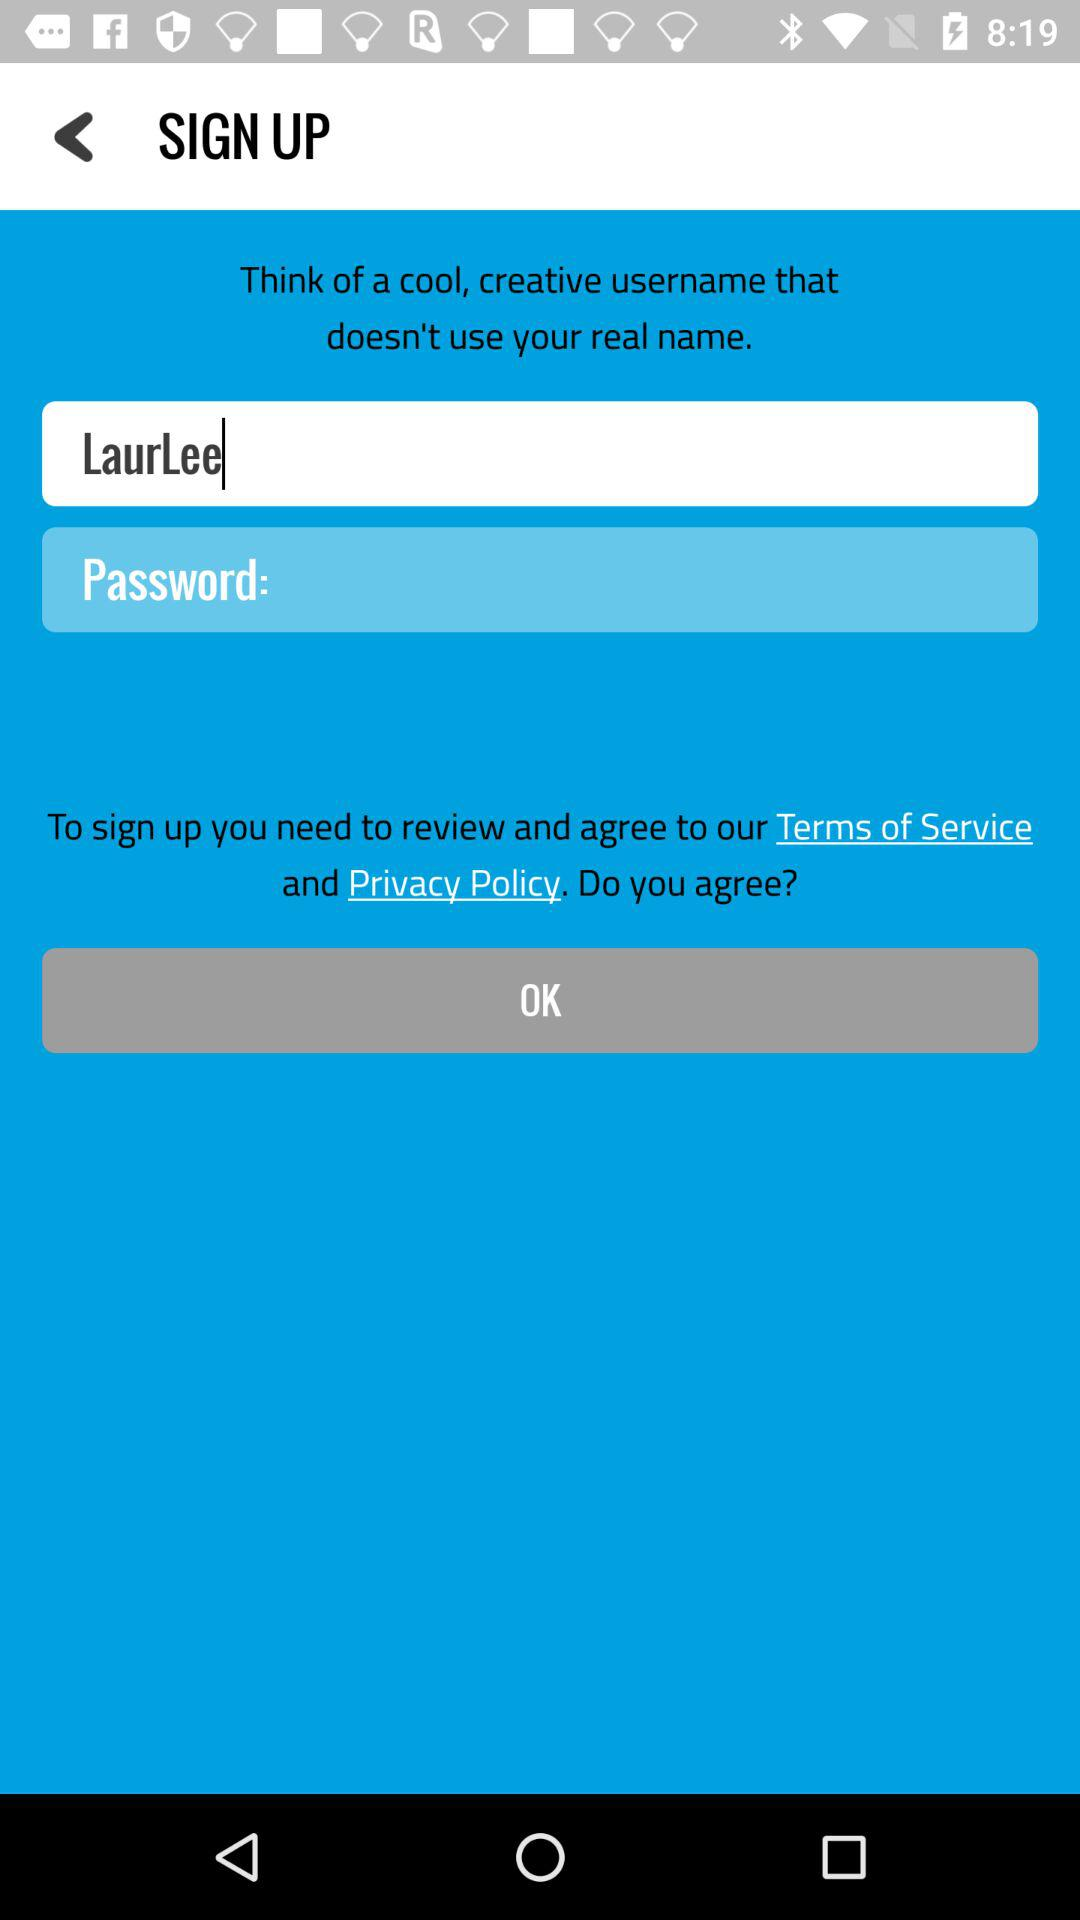What is the username? The username is "LaurLee". 